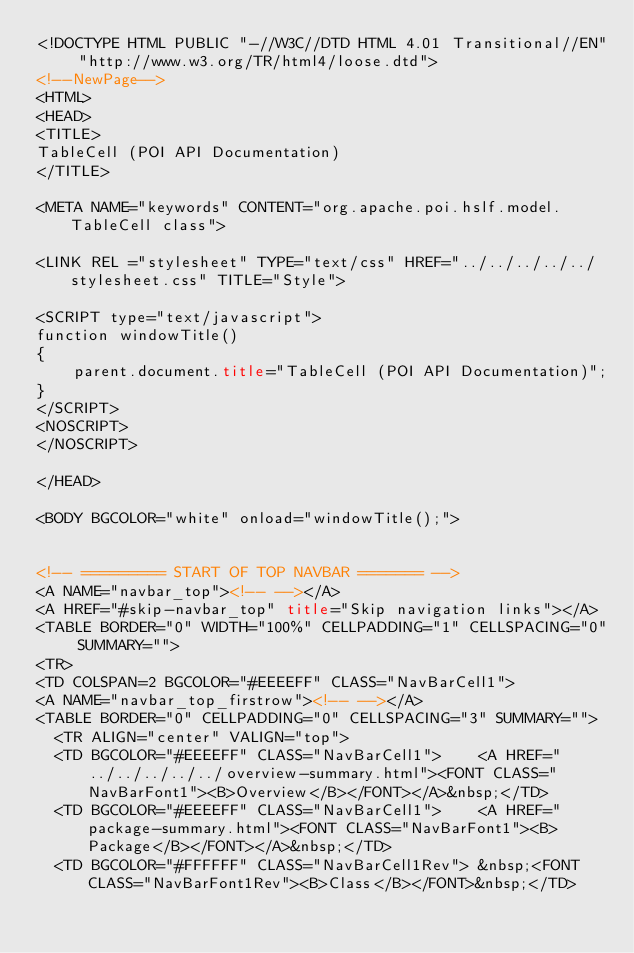<code> <loc_0><loc_0><loc_500><loc_500><_HTML_><!DOCTYPE HTML PUBLIC "-//W3C//DTD HTML 4.01 Transitional//EN" "http://www.w3.org/TR/html4/loose.dtd">
<!--NewPage-->
<HTML>
<HEAD>
<TITLE>
TableCell (POI API Documentation)
</TITLE>

<META NAME="keywords" CONTENT="org.apache.poi.hslf.model.TableCell class">

<LINK REL ="stylesheet" TYPE="text/css" HREF="../../../../../stylesheet.css" TITLE="Style">

<SCRIPT type="text/javascript">
function windowTitle()
{
    parent.document.title="TableCell (POI API Documentation)";
}
</SCRIPT>
<NOSCRIPT>
</NOSCRIPT>

</HEAD>

<BODY BGCOLOR="white" onload="windowTitle();">


<!-- ========= START OF TOP NAVBAR ======= -->
<A NAME="navbar_top"><!-- --></A>
<A HREF="#skip-navbar_top" title="Skip navigation links"></A>
<TABLE BORDER="0" WIDTH="100%" CELLPADDING="1" CELLSPACING="0" SUMMARY="">
<TR>
<TD COLSPAN=2 BGCOLOR="#EEEEFF" CLASS="NavBarCell1">
<A NAME="navbar_top_firstrow"><!-- --></A>
<TABLE BORDER="0" CELLPADDING="0" CELLSPACING="3" SUMMARY="">
  <TR ALIGN="center" VALIGN="top">
  <TD BGCOLOR="#EEEEFF" CLASS="NavBarCell1">    <A HREF="../../../../../overview-summary.html"><FONT CLASS="NavBarFont1"><B>Overview</B></FONT></A>&nbsp;</TD>
  <TD BGCOLOR="#EEEEFF" CLASS="NavBarCell1">    <A HREF="package-summary.html"><FONT CLASS="NavBarFont1"><B>Package</B></FONT></A>&nbsp;</TD>
  <TD BGCOLOR="#FFFFFF" CLASS="NavBarCell1Rev"> &nbsp;<FONT CLASS="NavBarFont1Rev"><B>Class</B></FONT>&nbsp;</TD></code> 